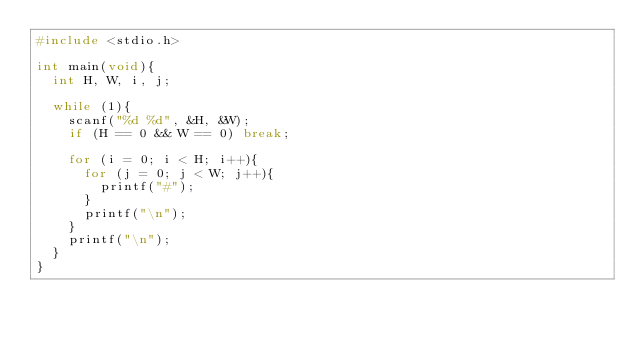<code> <loc_0><loc_0><loc_500><loc_500><_C_>#include <stdio.h>

int main(void){
	int H, W, i, j;

	while (1){
		scanf("%d %d", &H, &W);
		if (H == 0 && W == 0) break;

		for (i = 0; i < H; i++){
			for (j = 0; j < W; j++){
				printf("#");
			}
			printf("\n");
		}
		printf("\n");
	}
}</code> 